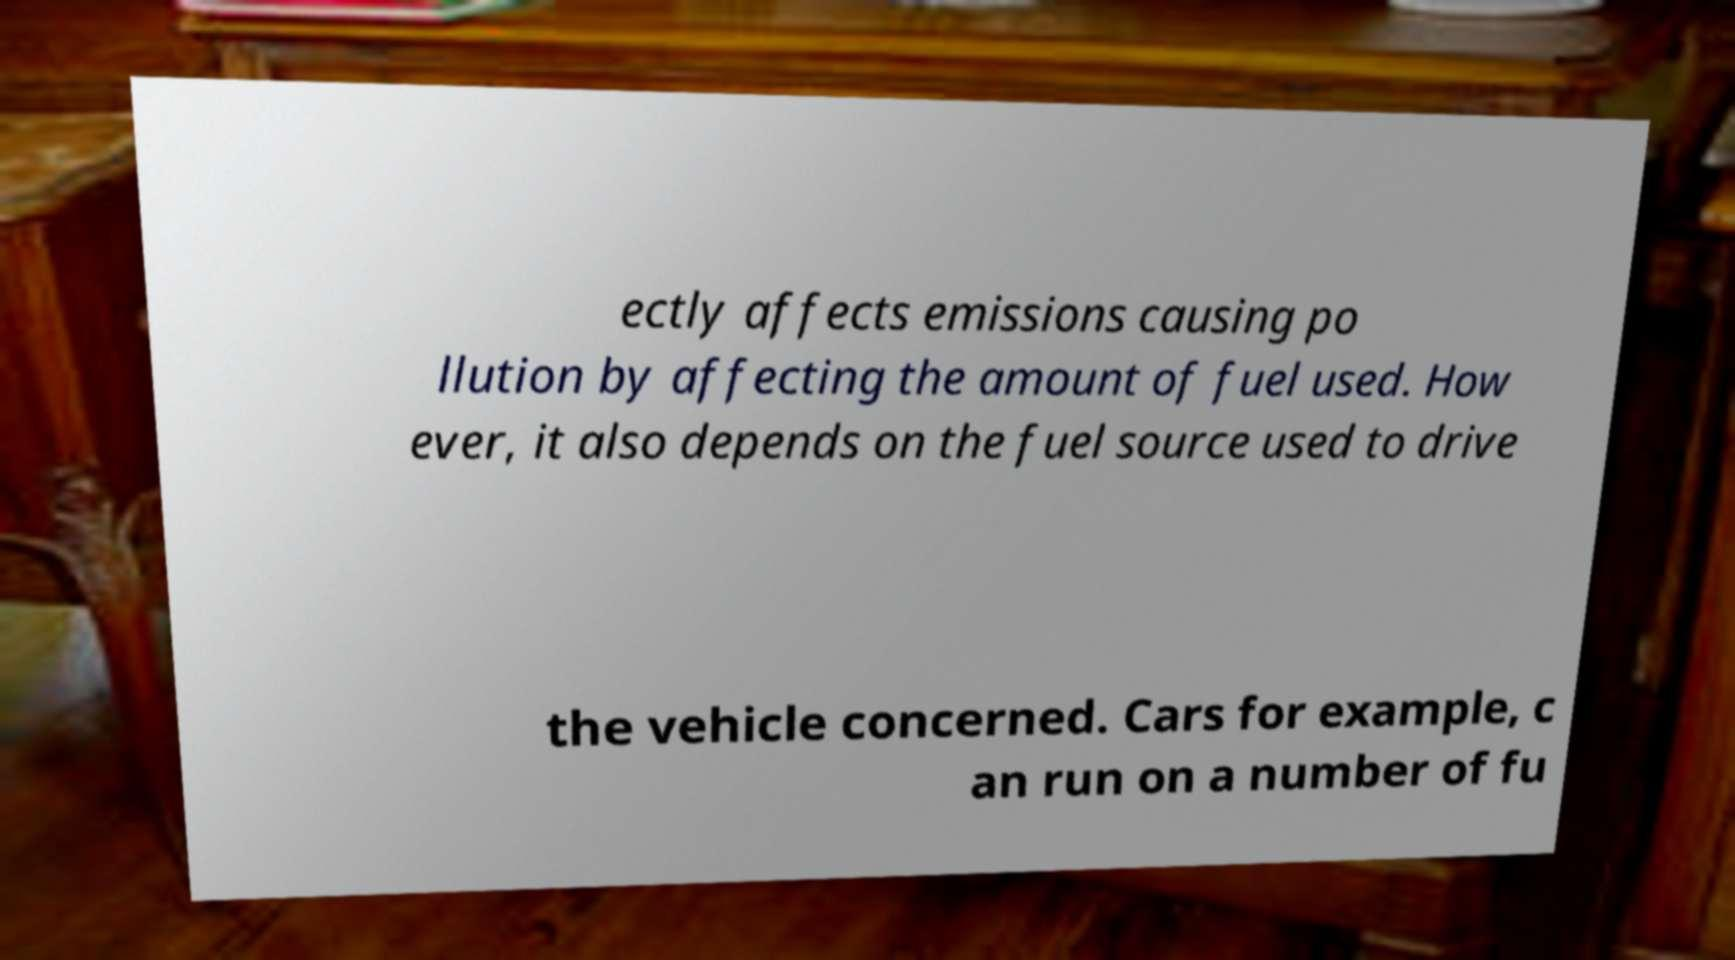Could you extract and type out the text from this image? ectly affects emissions causing po llution by affecting the amount of fuel used. How ever, it also depends on the fuel source used to drive the vehicle concerned. Cars for example, c an run on a number of fu 